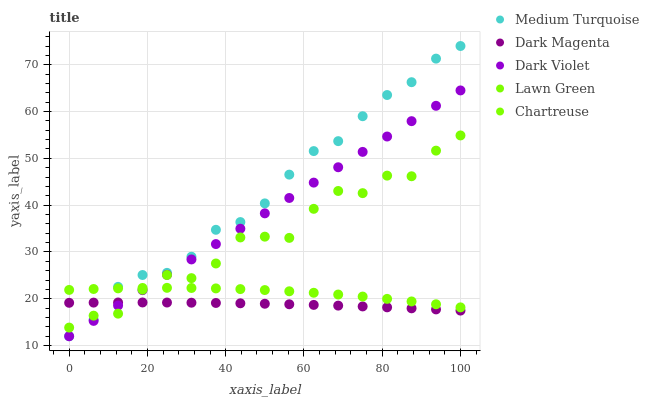Does Dark Magenta have the minimum area under the curve?
Answer yes or no. Yes. Does Medium Turquoise have the maximum area under the curve?
Answer yes or no. Yes. Does Dark Violet have the minimum area under the curve?
Answer yes or no. No. Does Dark Violet have the maximum area under the curve?
Answer yes or no. No. Is Dark Violet the smoothest?
Answer yes or no. Yes. Is Lawn Green the roughest?
Answer yes or no. Yes. Is Dark Magenta the smoothest?
Answer yes or no. No. Is Dark Magenta the roughest?
Answer yes or no. No. Does Dark Violet have the lowest value?
Answer yes or no. Yes. Does Dark Magenta have the lowest value?
Answer yes or no. No. Does Medium Turquoise have the highest value?
Answer yes or no. Yes. Does Dark Violet have the highest value?
Answer yes or no. No. Is Dark Magenta less than Chartreuse?
Answer yes or no. Yes. Is Chartreuse greater than Dark Magenta?
Answer yes or no. Yes. Does Lawn Green intersect Chartreuse?
Answer yes or no. Yes. Is Lawn Green less than Chartreuse?
Answer yes or no. No. Is Lawn Green greater than Chartreuse?
Answer yes or no. No. Does Dark Magenta intersect Chartreuse?
Answer yes or no. No. 